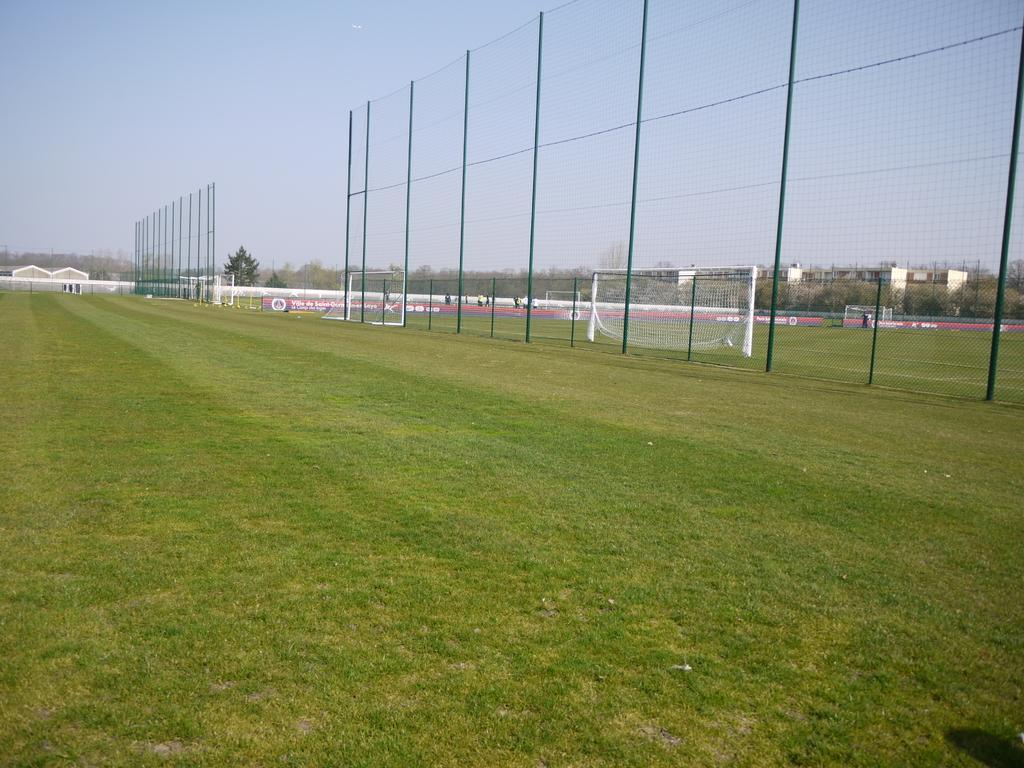Please provide a concise description of this image. In this image in the front there's grass on the ground. In the center there is a fence and in the background there are trees and there are buildings. 